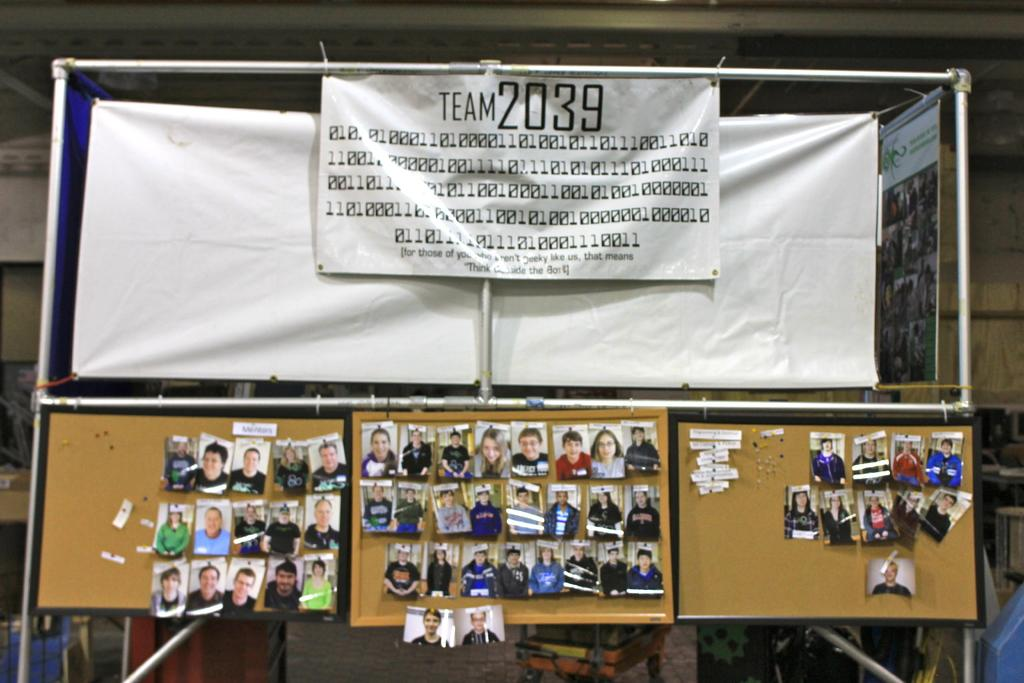<image>
Present a compact description of the photo's key features. a banner for a team with the number 2039 